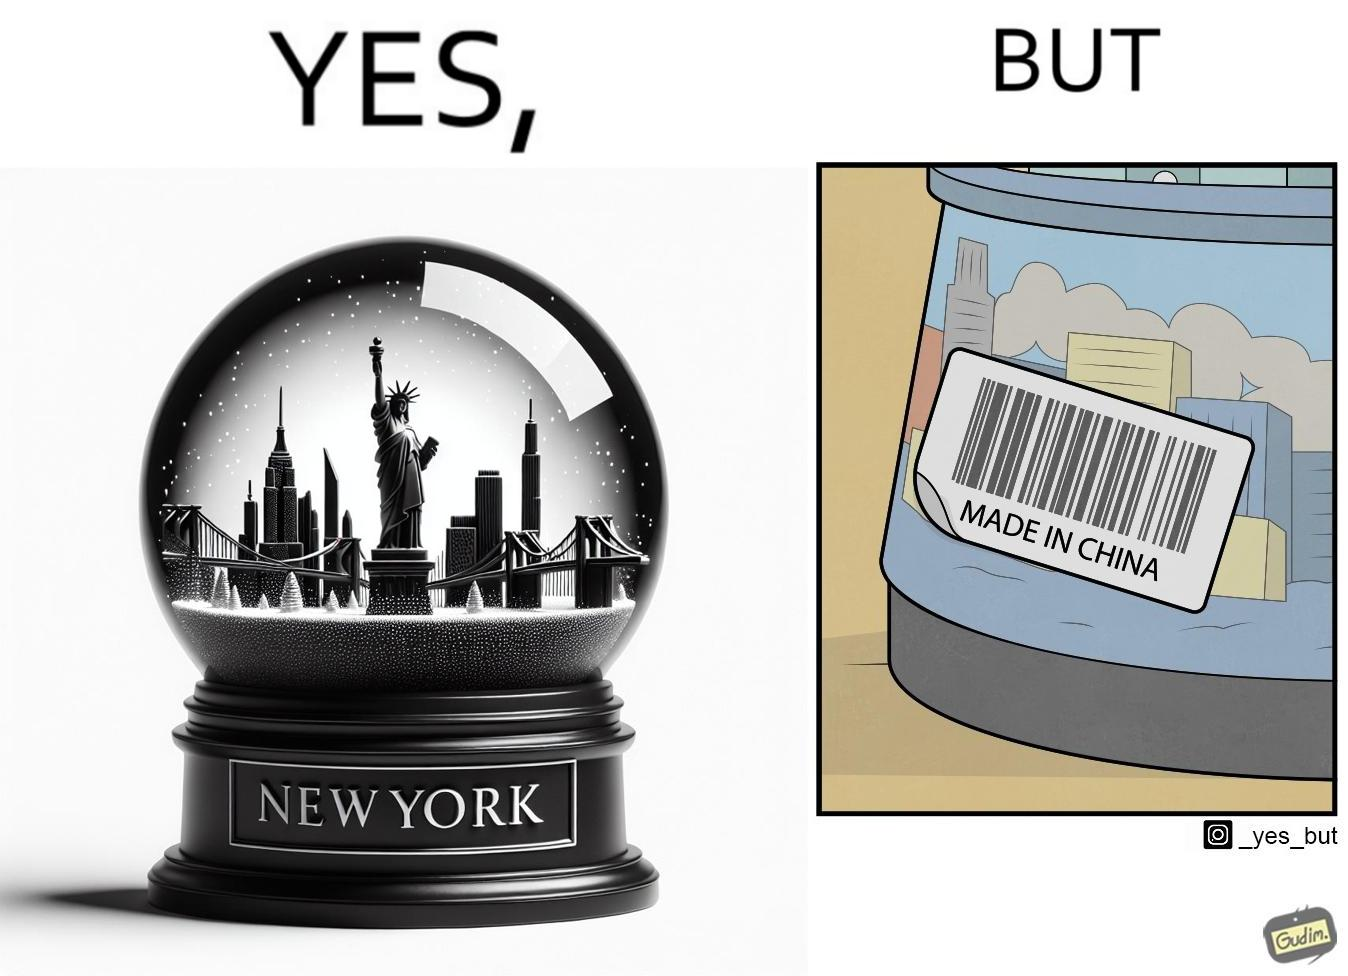What does this image depict? The image is ironic because the snowglobe says 'New York' while it is made in China 